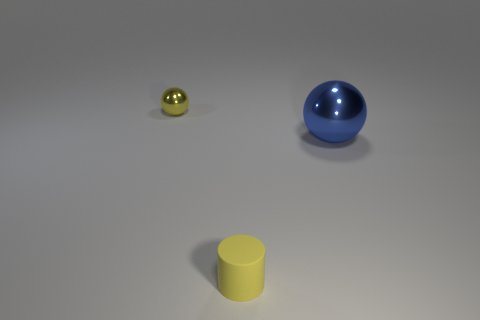There is a tiny yellow sphere; what number of metallic objects are right of it?
Give a very brief answer. 1. How many things are either large blue metallic things on the right side of the tiny rubber object or tiny balls?
Your answer should be compact. 2. Are there more yellow objects that are on the left side of the yellow matte cylinder than cylinders on the left side of the yellow shiny sphere?
Your response must be concise. Yes. There is a matte thing; does it have the same size as the metal ball that is to the right of the tiny yellow cylinder?
Keep it short and to the point. No. How many cylinders are either yellow metallic objects or large metallic objects?
Provide a succinct answer. 0. There is a yellow thing that is made of the same material as the blue sphere; what size is it?
Offer a terse response. Small. There is a yellow thing in front of the tiny yellow shiny object; does it have the same size as the metal thing in front of the tiny sphere?
Your response must be concise. No. What number of things are either small yellow rubber cylinders or small brown matte blocks?
Ensure brevity in your answer.  1. What is the shape of the tiny rubber object?
Give a very brief answer. Cylinder. The other thing that is the same shape as the tiny yellow metallic object is what size?
Your response must be concise. Large. 